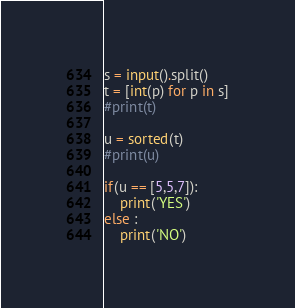<code> <loc_0><loc_0><loc_500><loc_500><_Python_>s = input().split()
t = [int(p) for p in s]
#print(t)

u = sorted(t)
#print(u)

if(u == [5,5,7]):
    print('YES')
else :
    print('NO')</code> 